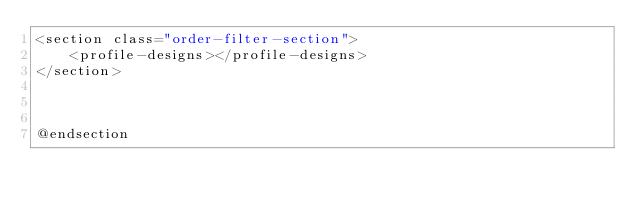<code> <loc_0><loc_0><loc_500><loc_500><_PHP_><section class="order-filter-section">
    <profile-designs></profile-designs>
</section>



@endsection
</code> 